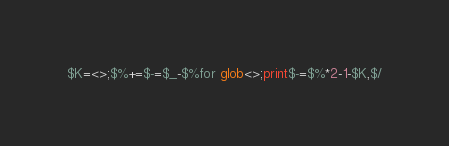Convert code to text. <code><loc_0><loc_0><loc_500><loc_500><_Perl_>$K=<>;$%+=$-=$_-$%for glob<>;print$-=$%*2-1-$K,$/</code> 